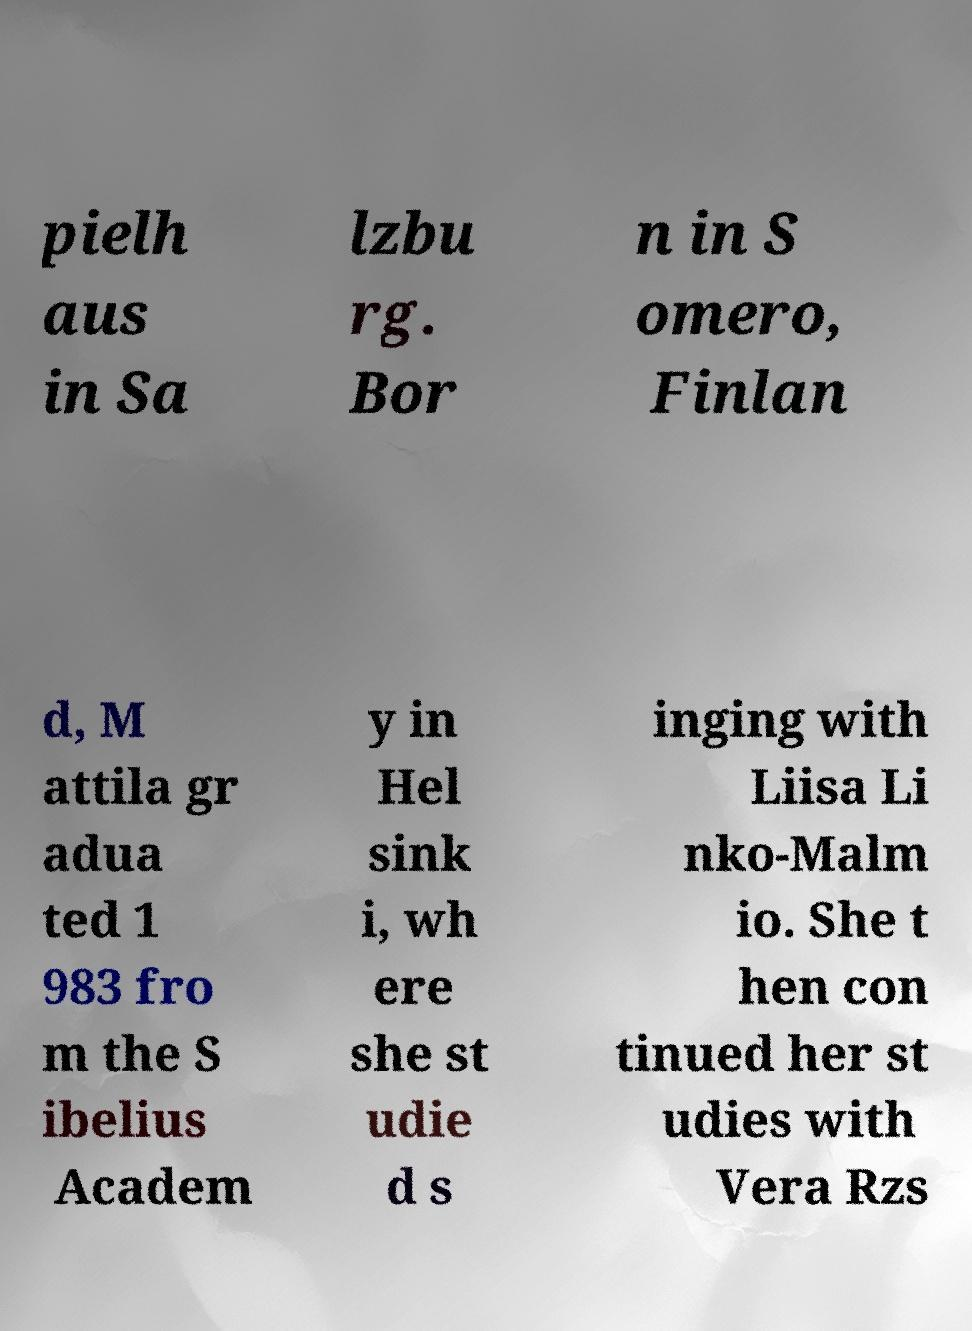Could you assist in decoding the text presented in this image and type it out clearly? pielh aus in Sa lzbu rg. Bor n in S omero, Finlan d, M attila gr adua ted 1 983 fro m the S ibelius Academ y in Hel sink i, wh ere she st udie d s inging with Liisa Li nko-Malm io. She t hen con tinued her st udies with Vera Rzs 